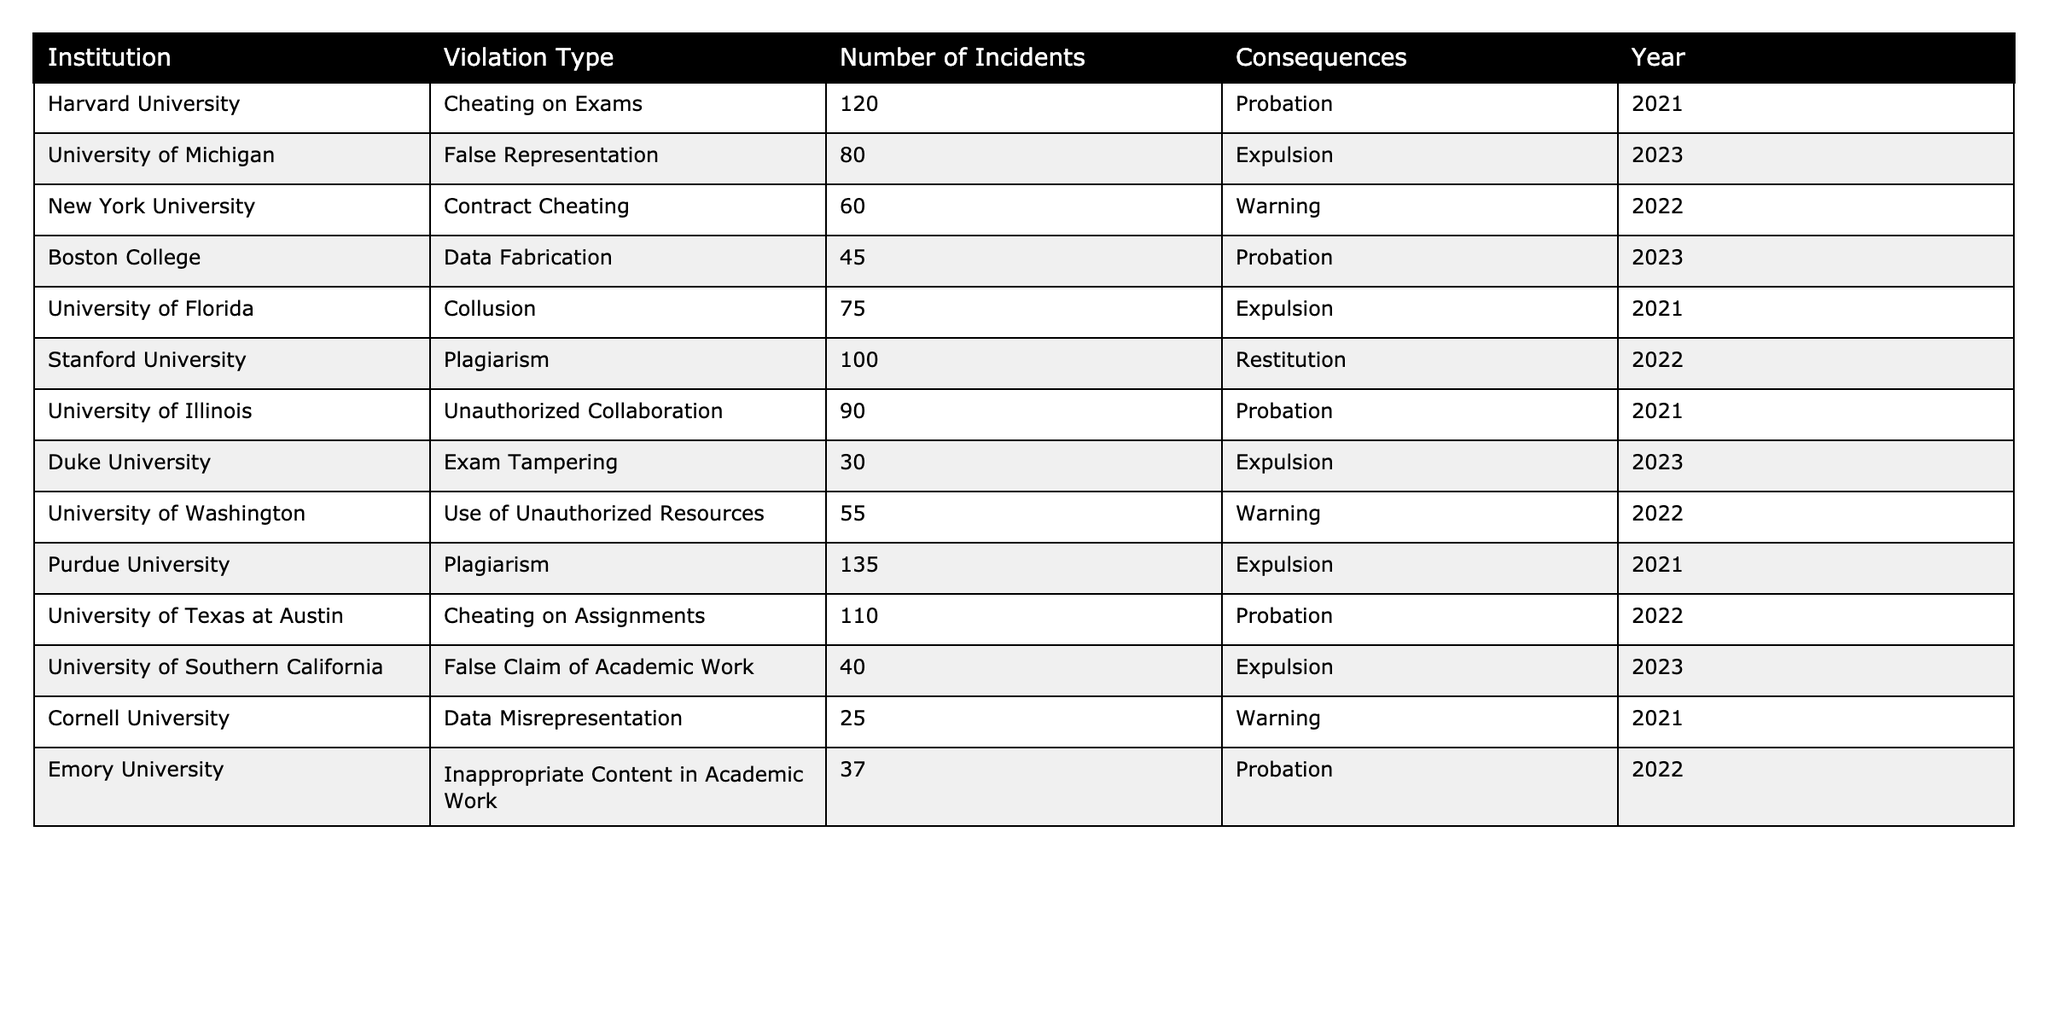What is the highest number of incidents recorded for a single institution? By examining the "Number of Incidents" column, we find that Purdue University has the highest value at 135 incidents.
Answer: 135 Which institution had the fewest incidents of academic integrity violations? Looking through the "Number of Incidents" column, Cornell University has the lowest count with just 25 incidents.
Answer: 25 What violation type is most associated with expulsion? Analyzing the "Violation Type" for those institutions marked with expulsion in the "Consequences" column, we notice that multiple types like "False Representation," "Collusion," "Plagiarism," and "Exam Tampering" occur, but "Plagiarism" and "Collusion" are each cited by two institutions.
Answer: Plagiarism, Collusion What is the total number of incidents that resulted in probation? We can sum the "Number of Incidents" for records where the "Consequences" are marked as probation, specifically for Harvard University, Boston College, University of Illinois, University of Texas at Austin, and Emory University. Summing these values gives 120 + 45 + 90 + 110 + 37 = 402.
Answer: 402 Compare the number of cheating incidents on exams versus assignments. From the "Number of Incidents" column, Harvard University has 120 incidents for cheating on exams, while the University of Texas at Austin has 110 incidents for cheating on assignments. The difference can be calculated as 120 - 110 = 10.
Answer: 10 Which institution had the most varied types of violations resulting in expulsion? Observing the "Consequences" column, four institutions have multiple violation types: University of Florida (Collusion), Purdue University (Plagiarism), University of Michigan (False Representation), and Duke University (Exam Tampering). However, Purdue University has the most incidents (135) associated with its violation type of Plagiarism.
Answer: Purdue University Is there a direct correlation between the number of incidents and the consequences given? Evaluating the data, we see various consequences: Expulsion, Warning, and Probation. Institutions with the most incidents (e.g., Purdue University and Harvard University) predominantly received Probation or Expulsion, but not all high incidents lead to the same consequences, indicating there's no direct correlation.
Answer: No What proportion of total incidents were due to cheating on exams? Adding all incidents gives a total of 685. The number of incidents specifically for cheating on exams is 120 for Harvard University. To find the proportion, we calculate (120 / 685) * 100 = approximately 17.5%.
Answer: 17.5% 